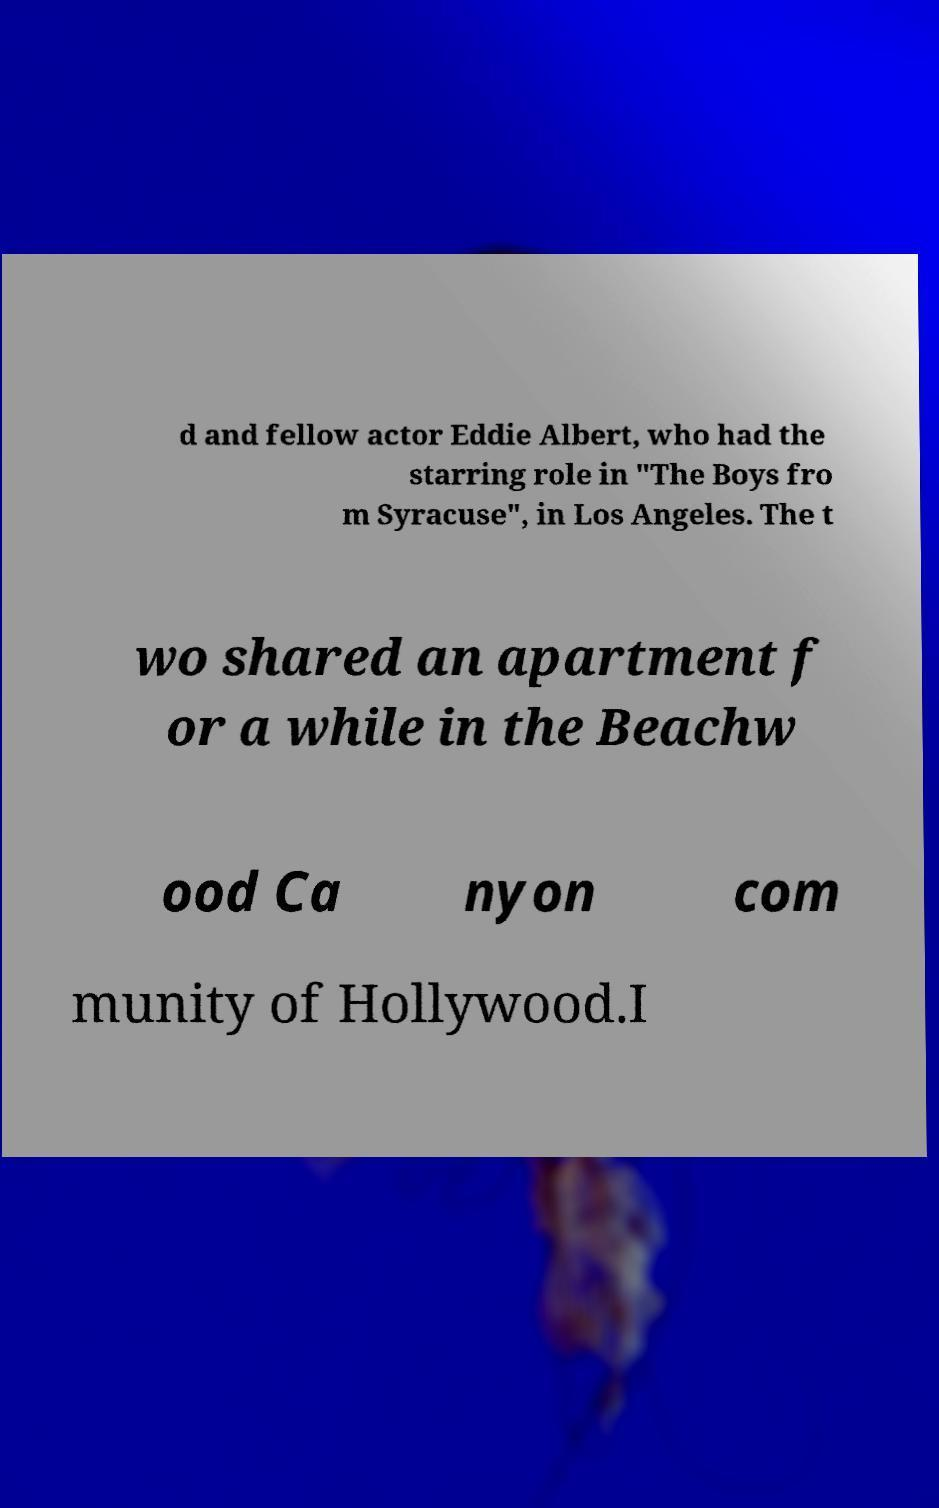Could you extract and type out the text from this image? d and fellow actor Eddie Albert, who had the starring role in "The Boys fro m Syracuse", in Los Angeles. The t wo shared an apartment f or a while in the Beachw ood Ca nyon com munity of Hollywood.I 